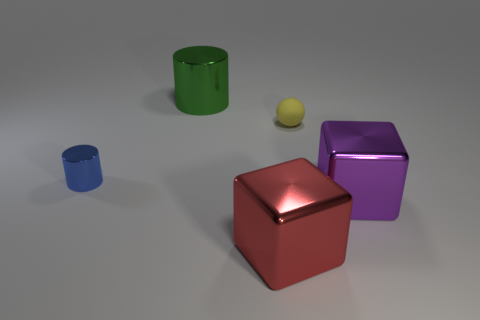Are there any other things that are the same material as the tiny yellow sphere?
Ensure brevity in your answer.  No. Does the cylinder behind the blue object have the same material as the yellow object?
Offer a terse response. No. Are there the same number of purple shiny cubes that are behind the tiny ball and metal cylinders that are on the left side of the large metal cylinder?
Offer a terse response. No. There is a big thing on the right side of the big red shiny object that is on the right side of the big green metal cylinder; are there any blue things that are on the right side of it?
Your response must be concise. No. There is a large object behind the small cylinder; does it have the same shape as the metallic object that is left of the green metal thing?
Offer a very short reply. Yes. Is the number of large things that are behind the red metallic cube greater than the number of big metallic cylinders?
Make the answer very short. Yes. What number of objects are either big brown blocks or large things?
Offer a terse response. 3. The small rubber object has what color?
Give a very brief answer. Yellow. How many other objects are the same color as the tiny matte sphere?
Provide a succinct answer. 0. There is a small cylinder; are there any large blocks behind it?
Your answer should be very brief. No. 